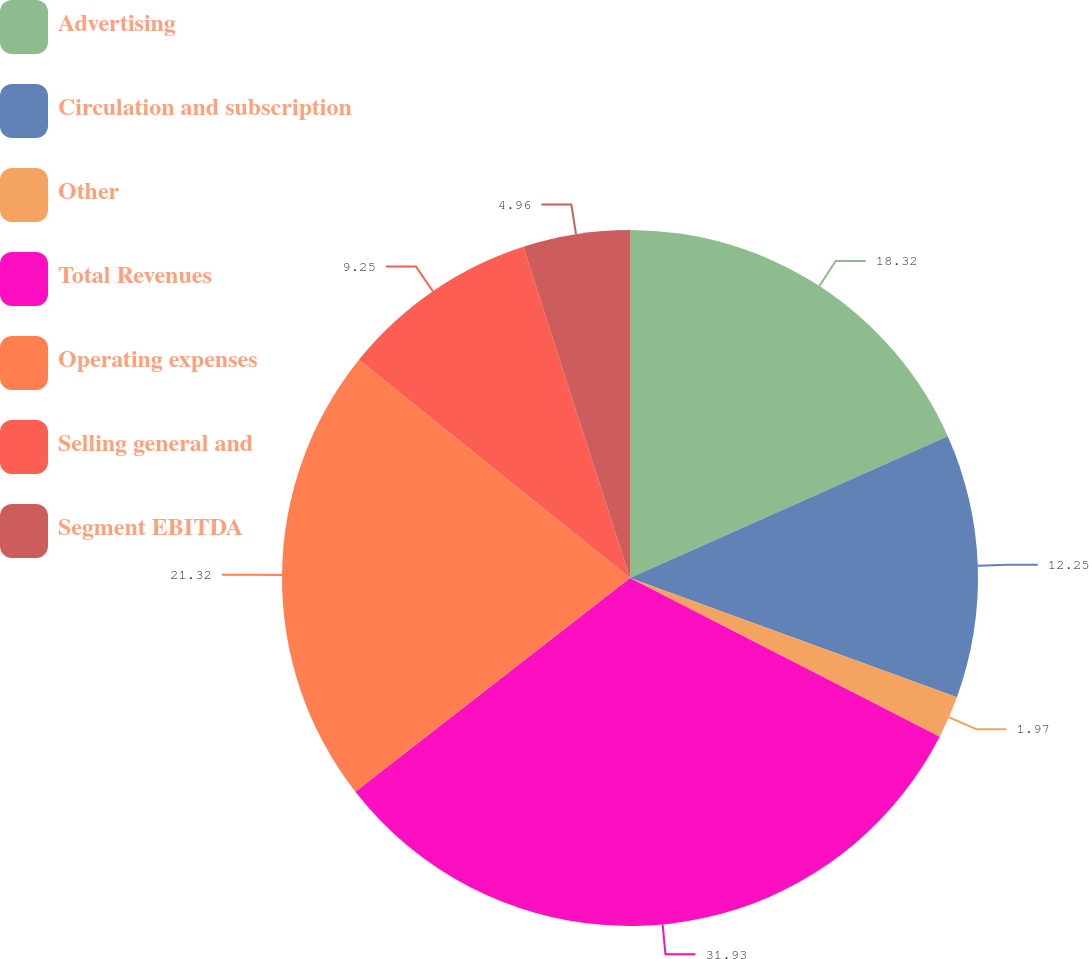<chart> <loc_0><loc_0><loc_500><loc_500><pie_chart><fcel>Advertising<fcel>Circulation and subscription<fcel>Other<fcel>Total Revenues<fcel>Operating expenses<fcel>Selling general and<fcel>Segment EBITDA<nl><fcel>18.32%<fcel>12.25%<fcel>1.97%<fcel>31.94%<fcel>21.32%<fcel>9.25%<fcel>4.96%<nl></chart> 